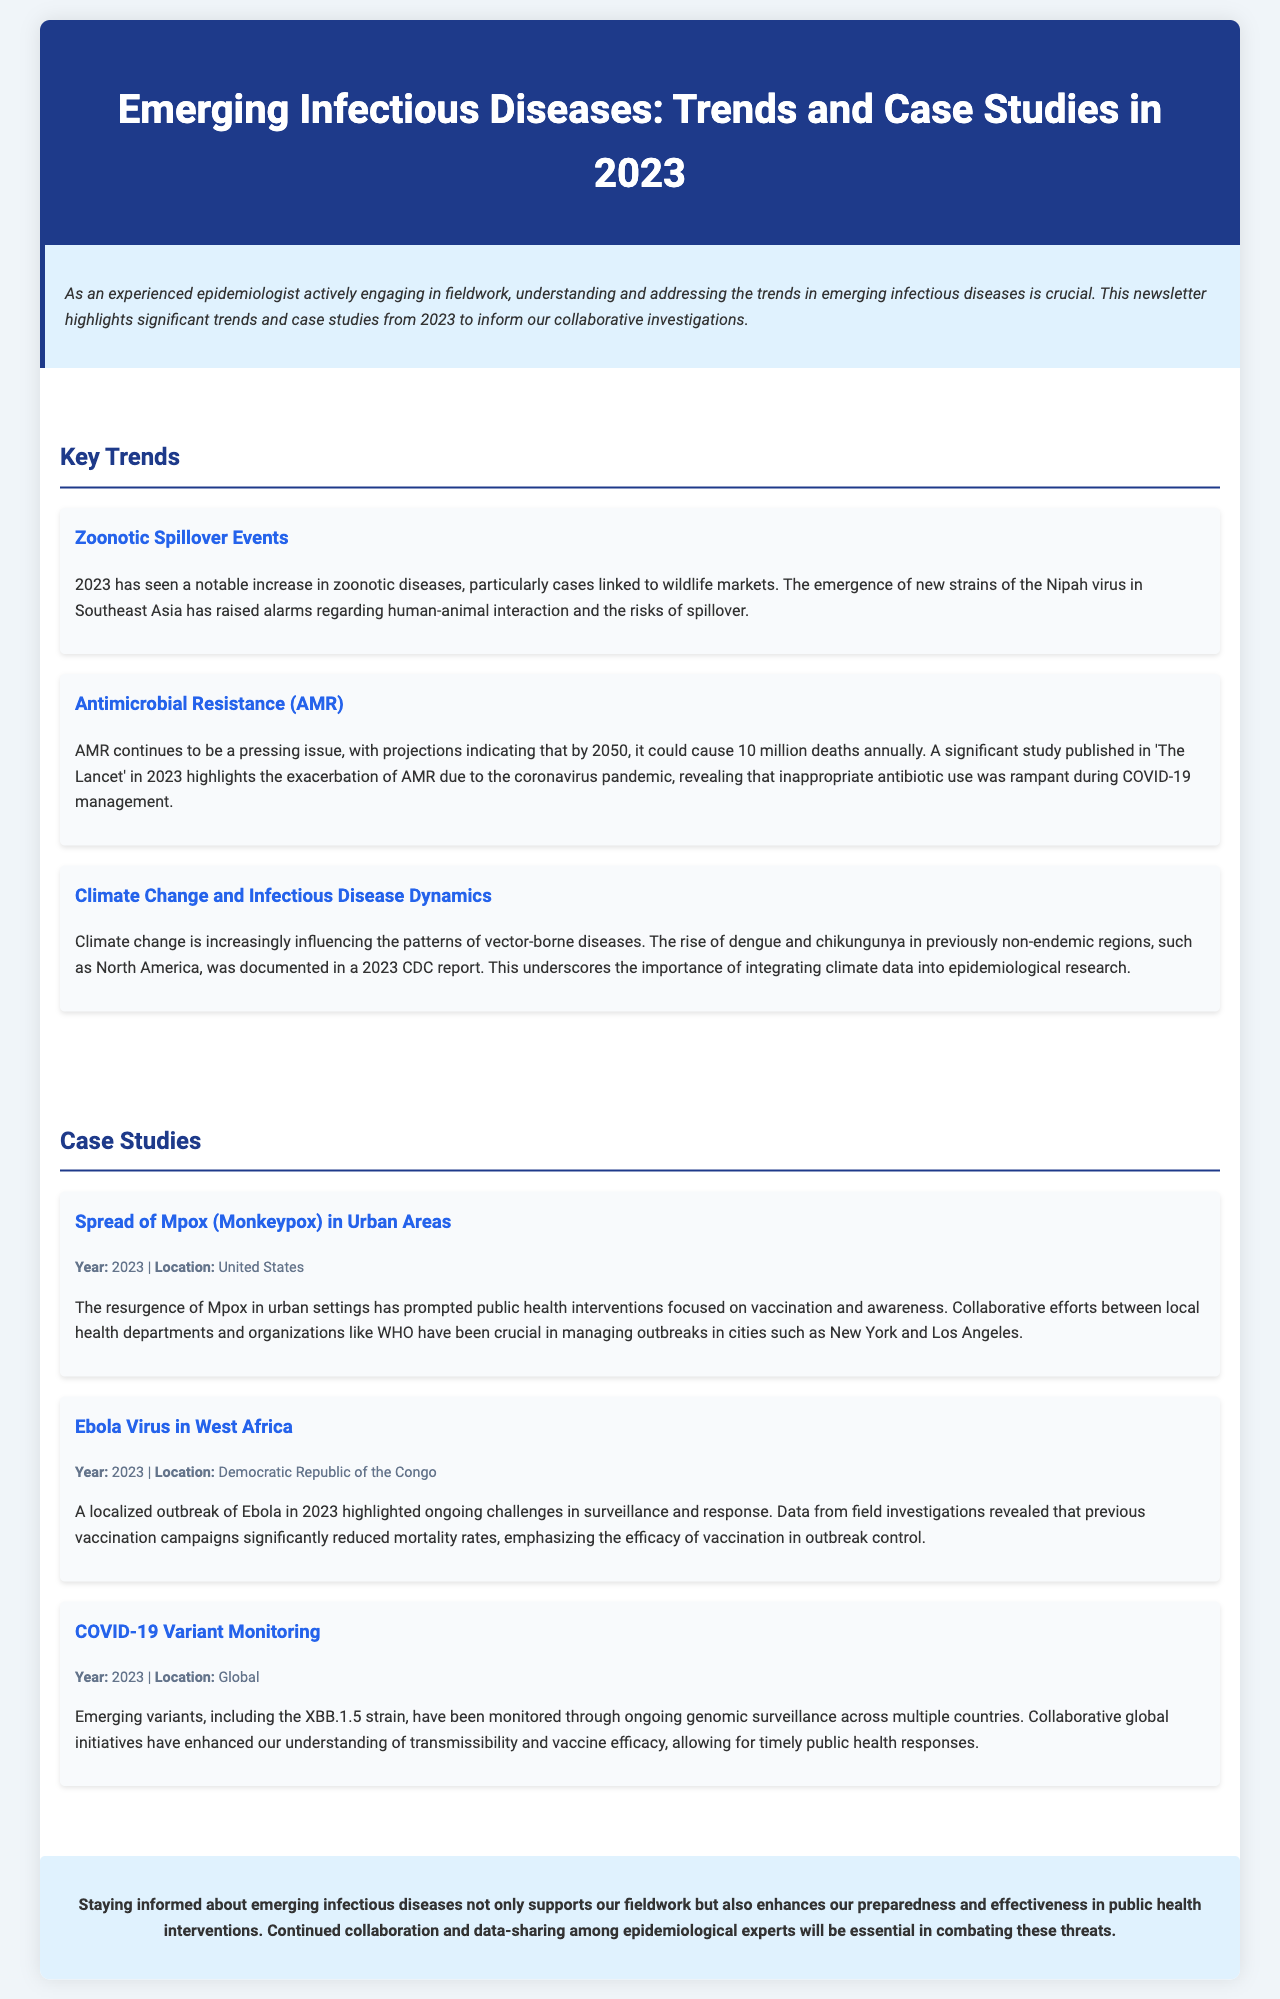what is the title of the newsletter? The title is stated in the header of the document, summarizing the topic discussed.
Answer: Emerging Infectious Diseases: Trends and Case Studies in 2023 what year did the Ebola outbreak occur in the Democratic Republic of the Congo? The case study section provides specific years related to each case.
Answer: 2023 which virus has seen a resurgence in urban areas according to the case studies? The document mentions the spread of a specific virus in urban settings.
Answer: Mpox (Monkeypox) what is the projected number of deaths due to antimicrobial resistance by 2050? The document includes projections related to antimicrobial resistance, specifically mentioning future death rates.
Answer: 10 million which continent is mentioned concerning the spread of dengue and chikungunya? The trends mention regions affected by dengue and chikungunya linked to climate change.
Answer: North America who collaborated with local health departments to manage Mpox outbreaks? The document describes collaborative efforts involving specific organizations during the Mpox outbreak.
Answer: WHO what is a pressing global issue exacerbated by the coronavirus pandemic? The trends section discusses significant issues in public health aggravated by the pandemic.
Answer: Antimicrobial Resistance (AMR) what is essential for combating emerging infectious diseases as stated in the conclusion? The conclusion emphasizes a key strategy for public health intervention effectiveness.
Answer: Data-sharing among epidemiological experts 